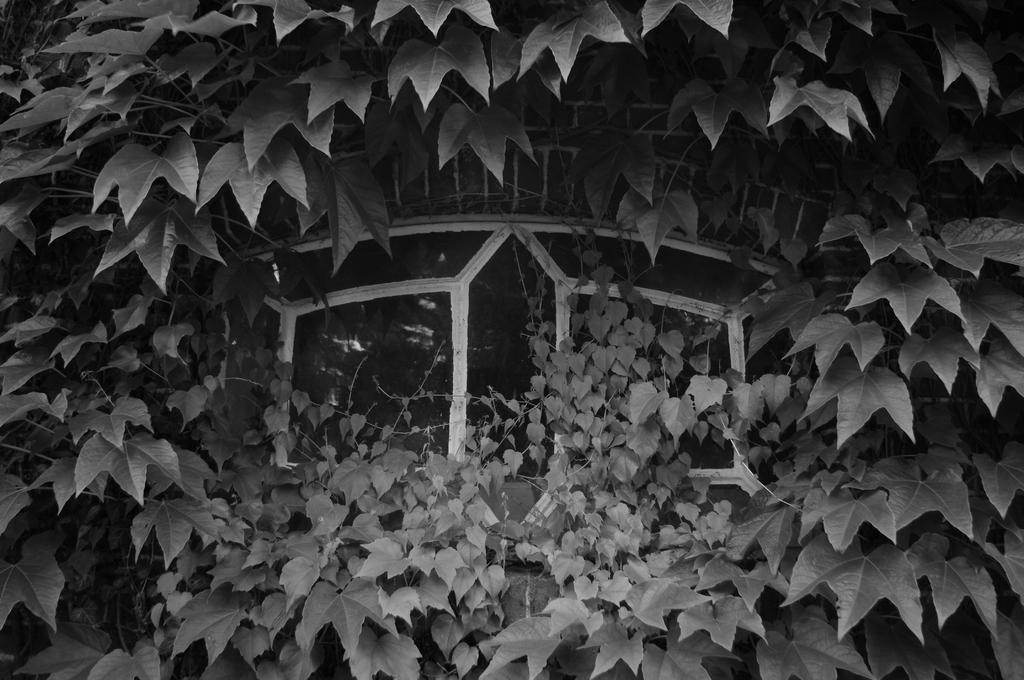Please provide a concise description of this image. This image is a black and white image. This image is taken outdoors. In this image there is a creeper with many leaves. In the middle of the image there is a window. 